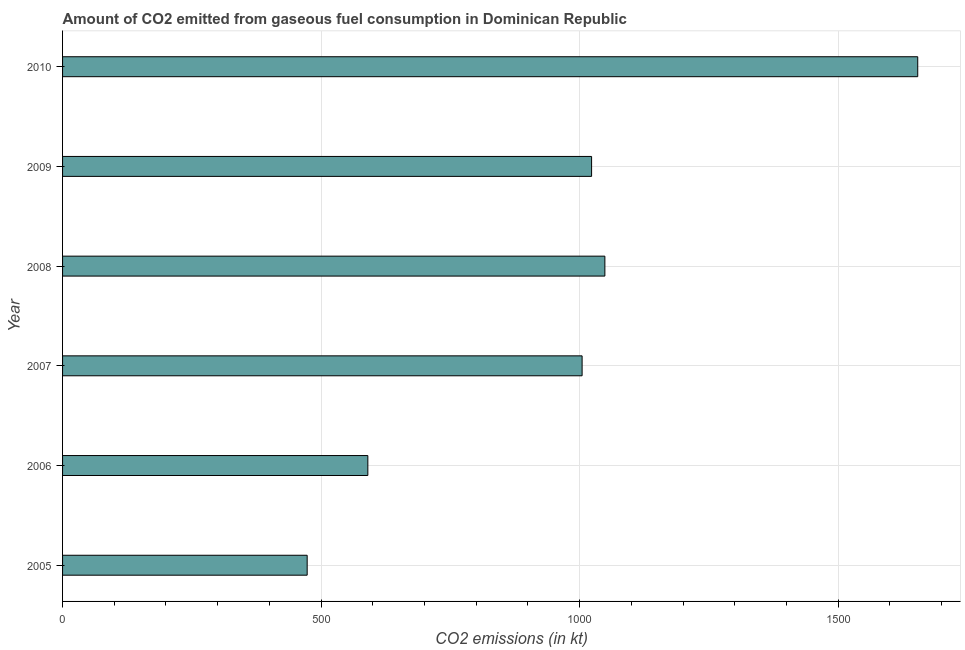Does the graph contain any zero values?
Provide a succinct answer. No. What is the title of the graph?
Provide a short and direct response. Amount of CO2 emitted from gaseous fuel consumption in Dominican Republic. What is the label or title of the X-axis?
Ensure brevity in your answer.  CO2 emissions (in kt). What is the co2 emissions from gaseous fuel consumption in 2007?
Provide a short and direct response. 1004.76. Across all years, what is the maximum co2 emissions from gaseous fuel consumption?
Provide a short and direct response. 1653.82. Across all years, what is the minimum co2 emissions from gaseous fuel consumption?
Make the answer very short. 473.04. In which year was the co2 emissions from gaseous fuel consumption minimum?
Offer a terse response. 2005. What is the sum of the co2 emissions from gaseous fuel consumption?
Keep it short and to the point. 5793.86. What is the difference between the co2 emissions from gaseous fuel consumption in 2006 and 2009?
Keep it short and to the point. -432.71. What is the average co2 emissions from gaseous fuel consumption per year?
Offer a very short reply. 965.64. What is the median co2 emissions from gaseous fuel consumption?
Keep it short and to the point. 1013.93. In how many years, is the co2 emissions from gaseous fuel consumption greater than 700 kt?
Provide a succinct answer. 4. What is the ratio of the co2 emissions from gaseous fuel consumption in 2008 to that in 2009?
Offer a terse response. 1.02. What is the difference between the highest and the second highest co2 emissions from gaseous fuel consumption?
Your response must be concise. 605.05. Is the sum of the co2 emissions from gaseous fuel consumption in 2008 and 2009 greater than the maximum co2 emissions from gaseous fuel consumption across all years?
Keep it short and to the point. Yes. What is the difference between the highest and the lowest co2 emissions from gaseous fuel consumption?
Offer a very short reply. 1180.77. How many bars are there?
Provide a succinct answer. 6. Are the values on the major ticks of X-axis written in scientific E-notation?
Offer a terse response. No. What is the CO2 emissions (in kt) of 2005?
Ensure brevity in your answer.  473.04. What is the CO2 emissions (in kt) in 2006?
Offer a terse response. 590.39. What is the CO2 emissions (in kt) in 2007?
Your response must be concise. 1004.76. What is the CO2 emissions (in kt) in 2008?
Your answer should be compact. 1048.76. What is the CO2 emissions (in kt) of 2009?
Provide a succinct answer. 1023.09. What is the CO2 emissions (in kt) in 2010?
Your response must be concise. 1653.82. What is the difference between the CO2 emissions (in kt) in 2005 and 2006?
Provide a short and direct response. -117.34. What is the difference between the CO2 emissions (in kt) in 2005 and 2007?
Your answer should be compact. -531.72. What is the difference between the CO2 emissions (in kt) in 2005 and 2008?
Ensure brevity in your answer.  -575.72. What is the difference between the CO2 emissions (in kt) in 2005 and 2009?
Offer a terse response. -550.05. What is the difference between the CO2 emissions (in kt) in 2005 and 2010?
Give a very brief answer. -1180.77. What is the difference between the CO2 emissions (in kt) in 2006 and 2007?
Provide a succinct answer. -414.37. What is the difference between the CO2 emissions (in kt) in 2006 and 2008?
Give a very brief answer. -458.38. What is the difference between the CO2 emissions (in kt) in 2006 and 2009?
Your response must be concise. -432.71. What is the difference between the CO2 emissions (in kt) in 2006 and 2010?
Ensure brevity in your answer.  -1063.43. What is the difference between the CO2 emissions (in kt) in 2007 and 2008?
Offer a terse response. -44. What is the difference between the CO2 emissions (in kt) in 2007 and 2009?
Your answer should be very brief. -18.34. What is the difference between the CO2 emissions (in kt) in 2007 and 2010?
Your answer should be compact. -649.06. What is the difference between the CO2 emissions (in kt) in 2008 and 2009?
Your response must be concise. 25.67. What is the difference between the CO2 emissions (in kt) in 2008 and 2010?
Offer a terse response. -605.05. What is the difference between the CO2 emissions (in kt) in 2009 and 2010?
Make the answer very short. -630.72. What is the ratio of the CO2 emissions (in kt) in 2005 to that in 2006?
Provide a short and direct response. 0.8. What is the ratio of the CO2 emissions (in kt) in 2005 to that in 2007?
Your answer should be compact. 0.47. What is the ratio of the CO2 emissions (in kt) in 2005 to that in 2008?
Your answer should be very brief. 0.45. What is the ratio of the CO2 emissions (in kt) in 2005 to that in 2009?
Offer a terse response. 0.46. What is the ratio of the CO2 emissions (in kt) in 2005 to that in 2010?
Provide a succinct answer. 0.29. What is the ratio of the CO2 emissions (in kt) in 2006 to that in 2007?
Offer a very short reply. 0.59. What is the ratio of the CO2 emissions (in kt) in 2006 to that in 2008?
Offer a very short reply. 0.56. What is the ratio of the CO2 emissions (in kt) in 2006 to that in 2009?
Give a very brief answer. 0.58. What is the ratio of the CO2 emissions (in kt) in 2006 to that in 2010?
Offer a very short reply. 0.36. What is the ratio of the CO2 emissions (in kt) in 2007 to that in 2008?
Provide a succinct answer. 0.96. What is the ratio of the CO2 emissions (in kt) in 2007 to that in 2010?
Your answer should be very brief. 0.61. What is the ratio of the CO2 emissions (in kt) in 2008 to that in 2009?
Your response must be concise. 1.02. What is the ratio of the CO2 emissions (in kt) in 2008 to that in 2010?
Make the answer very short. 0.63. What is the ratio of the CO2 emissions (in kt) in 2009 to that in 2010?
Make the answer very short. 0.62. 